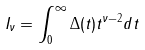Convert formula to latex. <formula><loc_0><loc_0><loc_500><loc_500>I _ { \nu } = \int _ { 0 } ^ { \infty } \Delta ( t ) t ^ { \nu - 2 } d t</formula> 